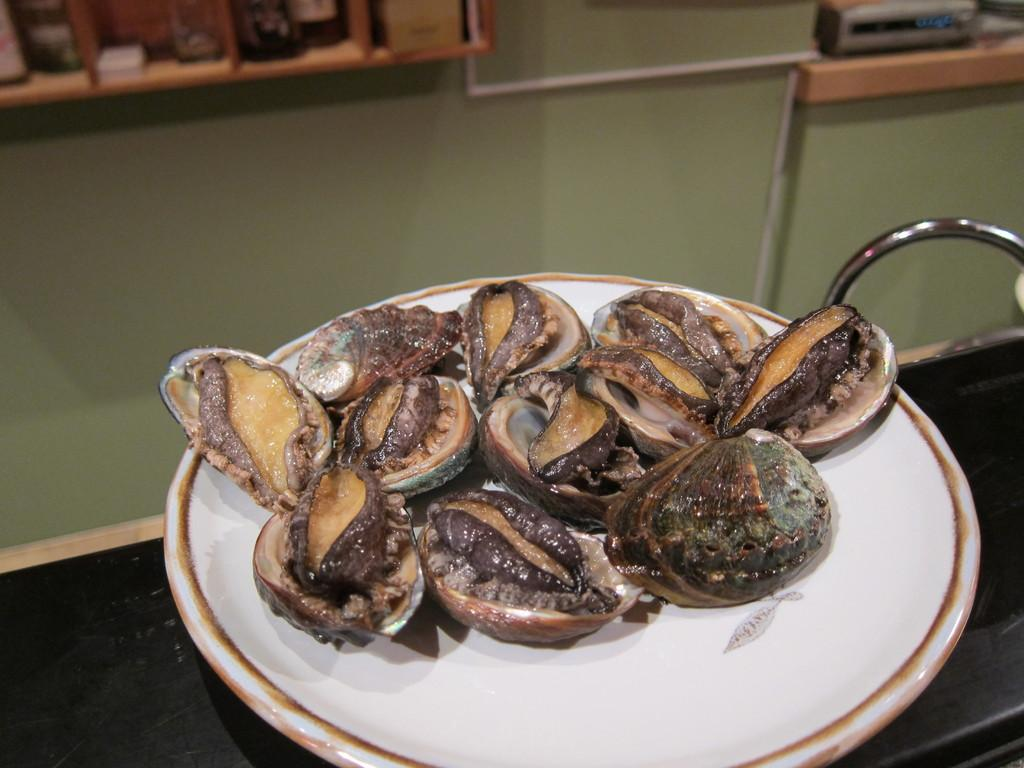What is on the plate that is visible in the image? There is a food item on a plate in the image. Where is the plate located in the image? The plate is placed on a surface in the image. What can be seen in the background of the image? There is a wall visible in the background of the image, and objects are placed on a shelf. How many feet are visible in the image? There are no feet visible in the image. What type of whip is being used to prepare the food item in the image? There is no whip present in the image, and the food item does not require preparation. 